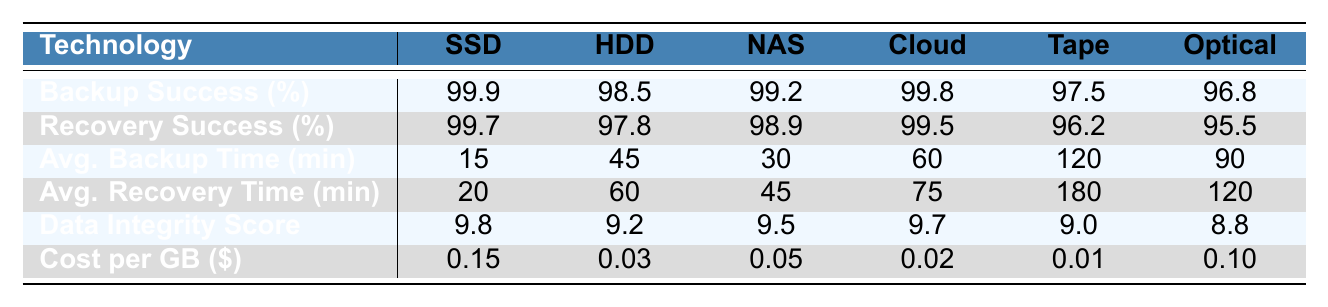What is the backup success rate of Cloud Storage? The table lists the backup success rates, and under Cloud Storage, the value is 99.8%.
Answer: 99.8% Which storage technology has the highest recovery success rate? By comparing the recovery success rates listed in the table, Solid State Drive (SSD) has the highest rate at 99.7%.
Answer: Solid State Drive (SSD) What is the average backup time for Tape Backup? The average backup time for Tape Backup is directly stated in the table as 120 minutes.
Answer: 120 minutes Is the data integrity score for Optical Disk greater than that of Tape Backup? Optical Disk has a data integrity score of 8.8, while Tape Backup has a score of 9.0. Thus, Optical Disk is not greater than Tape Backup.
Answer: No What is the difference in recovery success rates between SSD and HDD? The recovery success rate for SSD is 99.7%, while for HDD, it is 97.8%. The difference is 99.7% - 97.8% = 1.9%.
Answer: 1.9% What is the average cost per gigabyte of all storage technologies? Adding up the costs per GB (0.15 + 0.03 + 0.05 + 0.02 + 0.01 + 0.10) yields 0.36. Dividing by 6 gives an average cost of 0.06.
Answer: 0.06 Is the average recovery time longer for HDD compared to SSD? The average recovery time for HDD is 60 minutes and for SSD, it's 20 minutes. Since 60 minutes is greater than 20 minutes, the statement is true.
Answer: Yes Which storage technology has the lowest backup success rate, and what is that rate? The backup success rates are compared, and Tape Backup has the lowest rate at 97.5%.
Answer: Tape Backup, 97.5% If you were to rank the storage technologies by data integrity score from highest to lowest, which would be the second highest? The data integrity scores are: SSD (9.8), Cloud Storage (9.7), NAS (9.5), HDD (9.2), Tape Backup (9.0), Optical Disk (8.8). The second highest is Cloud Storage at 9.7.
Answer: Cloud Storage What is the average recovery time for all storage technologies? Adding the recovery times (20 + 60 + 45 + 75 + 180 + 120) results in 500 minutes. Dividing by 6 gives an average of approximately 83.33 minutes.
Answer: 83.33 minutes 